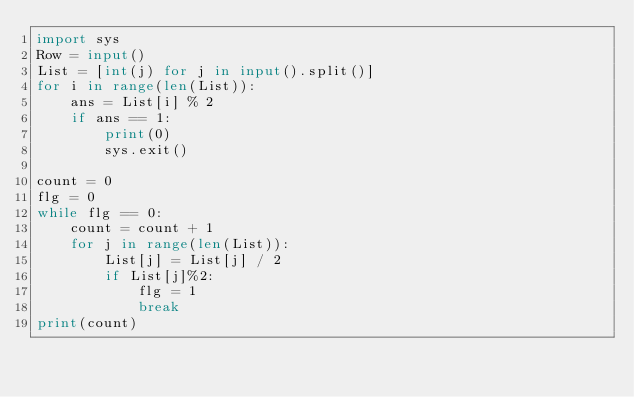<code> <loc_0><loc_0><loc_500><loc_500><_Python_>import sys
Row = input()
List = [int(j) for j in input().split()]
for i in range(len(List)):
    ans = List[i] % 2
    if ans == 1:
        print(0)
        sys.exit()

count = 0
flg = 0
while flg == 0:
    count = count + 1
    for j in range(len(List)):
        List[j] = List[j] / 2
        if List[j]%2:
            flg = 1
            break
print(count)
</code> 